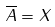<formula> <loc_0><loc_0><loc_500><loc_500>\overline { A } = X</formula> 